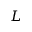<formula> <loc_0><loc_0><loc_500><loc_500>L</formula> 